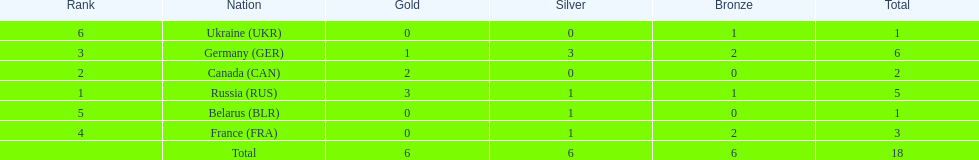Which country won the same amount of silver medals as the french and the russians? Belarus. 